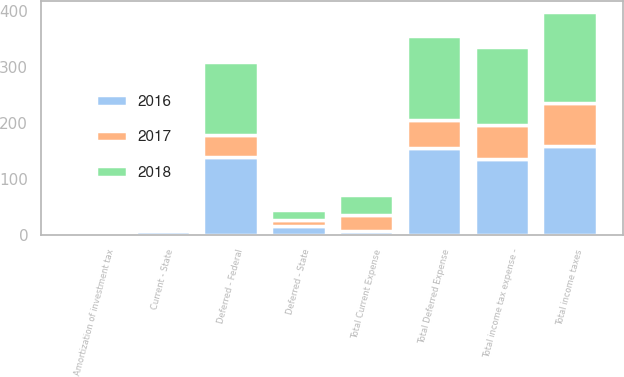<chart> <loc_0><loc_0><loc_500><loc_500><stacked_bar_chart><ecel><fcel>Current - State<fcel>Total Current Expense<fcel>Deferred - Federal<fcel>Deferred - State<fcel>Total Deferred Expense<fcel>Amortization of investment tax<fcel>Total income taxes<fcel>Total income tax expense -<nl><fcel>2017<fcel>6<fcel>28<fcel>40<fcel>10<fcel>50<fcel>2<fcel>76<fcel>60<nl><fcel>2016<fcel>7<fcel>7<fcel>138<fcel>16<fcel>154<fcel>2<fcel>159<fcel>136<nl><fcel>2018<fcel>5<fcel>36<fcel>131<fcel>19<fcel>150<fcel>2<fcel>163<fcel>139<nl></chart> 